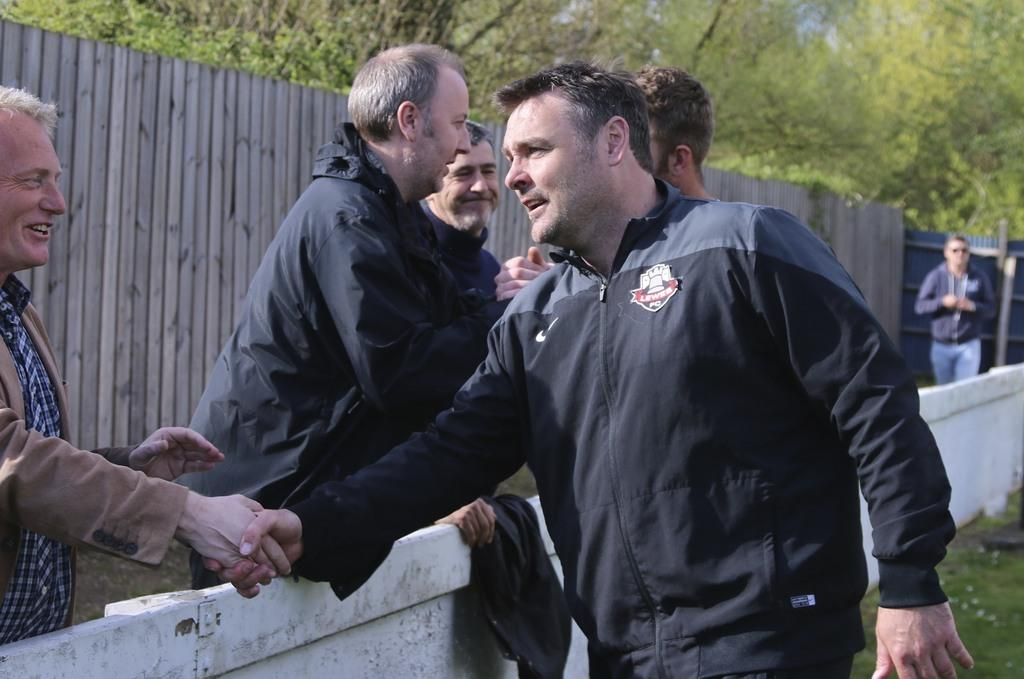How many people are in the image? There are people in the image, specifically two people shaking hands. What are the two people doing in the image? The two people are shaking hands. What can be seen in the background of the image? There is a wall, a wooden fence, and trees in the background. What type of tub is visible in the image? There is no tub present in the image. How many pigs are seen eating breakfast in the image? There are no pigs or breakfast depicted in the image. 